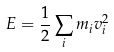Convert formula to latex. <formula><loc_0><loc_0><loc_500><loc_500>E = \frac { 1 } { 2 } \sum _ { i } m _ { i } v _ { i } ^ { 2 }</formula> 